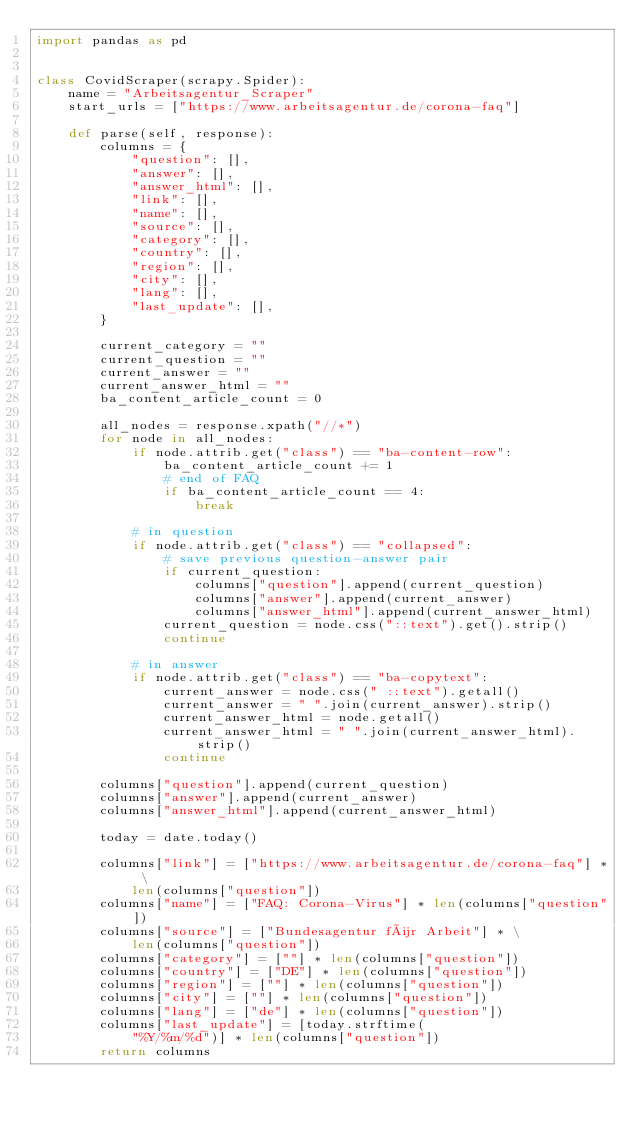Convert code to text. <code><loc_0><loc_0><loc_500><loc_500><_Python_>import pandas as pd


class CovidScraper(scrapy.Spider):
    name = "Arbeitsagentur_Scraper"
    start_urls = ["https://www.arbeitsagentur.de/corona-faq"]

    def parse(self, response):
        columns = {
            "question": [],
            "answer": [],
            "answer_html": [],
            "link": [],
            "name": [],
            "source": [],
            "category": [],
            "country": [],
            "region": [],
            "city": [],
            "lang": [],
            "last_update": [],
        }

        current_category = ""
        current_question = ""
        current_answer = ""
        current_answer_html = ""
        ba_content_article_count = 0

        all_nodes = response.xpath("//*")
        for node in all_nodes:
            if node.attrib.get("class") == "ba-content-row":
                ba_content_article_count += 1
                # end of FAQ 
                if ba_content_article_count == 4:
                    break

            # in question
            if node.attrib.get("class") == "collapsed":
                # save previous question-answer pair
                if current_question:
                    columns["question"].append(current_question)
                    columns["answer"].append(current_answer)
                    columns["answer_html"].append(current_answer_html)
                current_question = node.css("::text").get().strip()
                continue

            # in answer
            if node.attrib.get("class") == "ba-copytext":
                current_answer = node.css(" ::text").getall()
                current_answer = " ".join(current_answer).strip()
                current_answer_html = node.getall()
                current_answer_html = " ".join(current_answer_html).strip()
                continue

        columns["question"].append(current_question)
        columns["answer"].append(current_answer)
        columns["answer_html"].append(current_answer_html)

        today = date.today()

        columns["link"] = ["https://www.arbeitsagentur.de/corona-faq"] * \
            len(columns["question"])
        columns["name"] = ["FAQ: Corona-Virus"] * len(columns["question"])
        columns["source"] = ["Bundesagentur für Arbeit"] * \
            len(columns["question"])
        columns["category"] = [""] * len(columns["question"])
        columns["country"] = ["DE"] * len(columns["question"])
        columns["region"] = [""] * len(columns["question"])
        columns["city"] = [""] * len(columns["question"])
        columns["lang"] = ["de"] * len(columns["question"])
        columns["last_update"] = [today.strftime(
            "%Y/%m/%d")] * len(columns["question"])
        return columns
</code> 